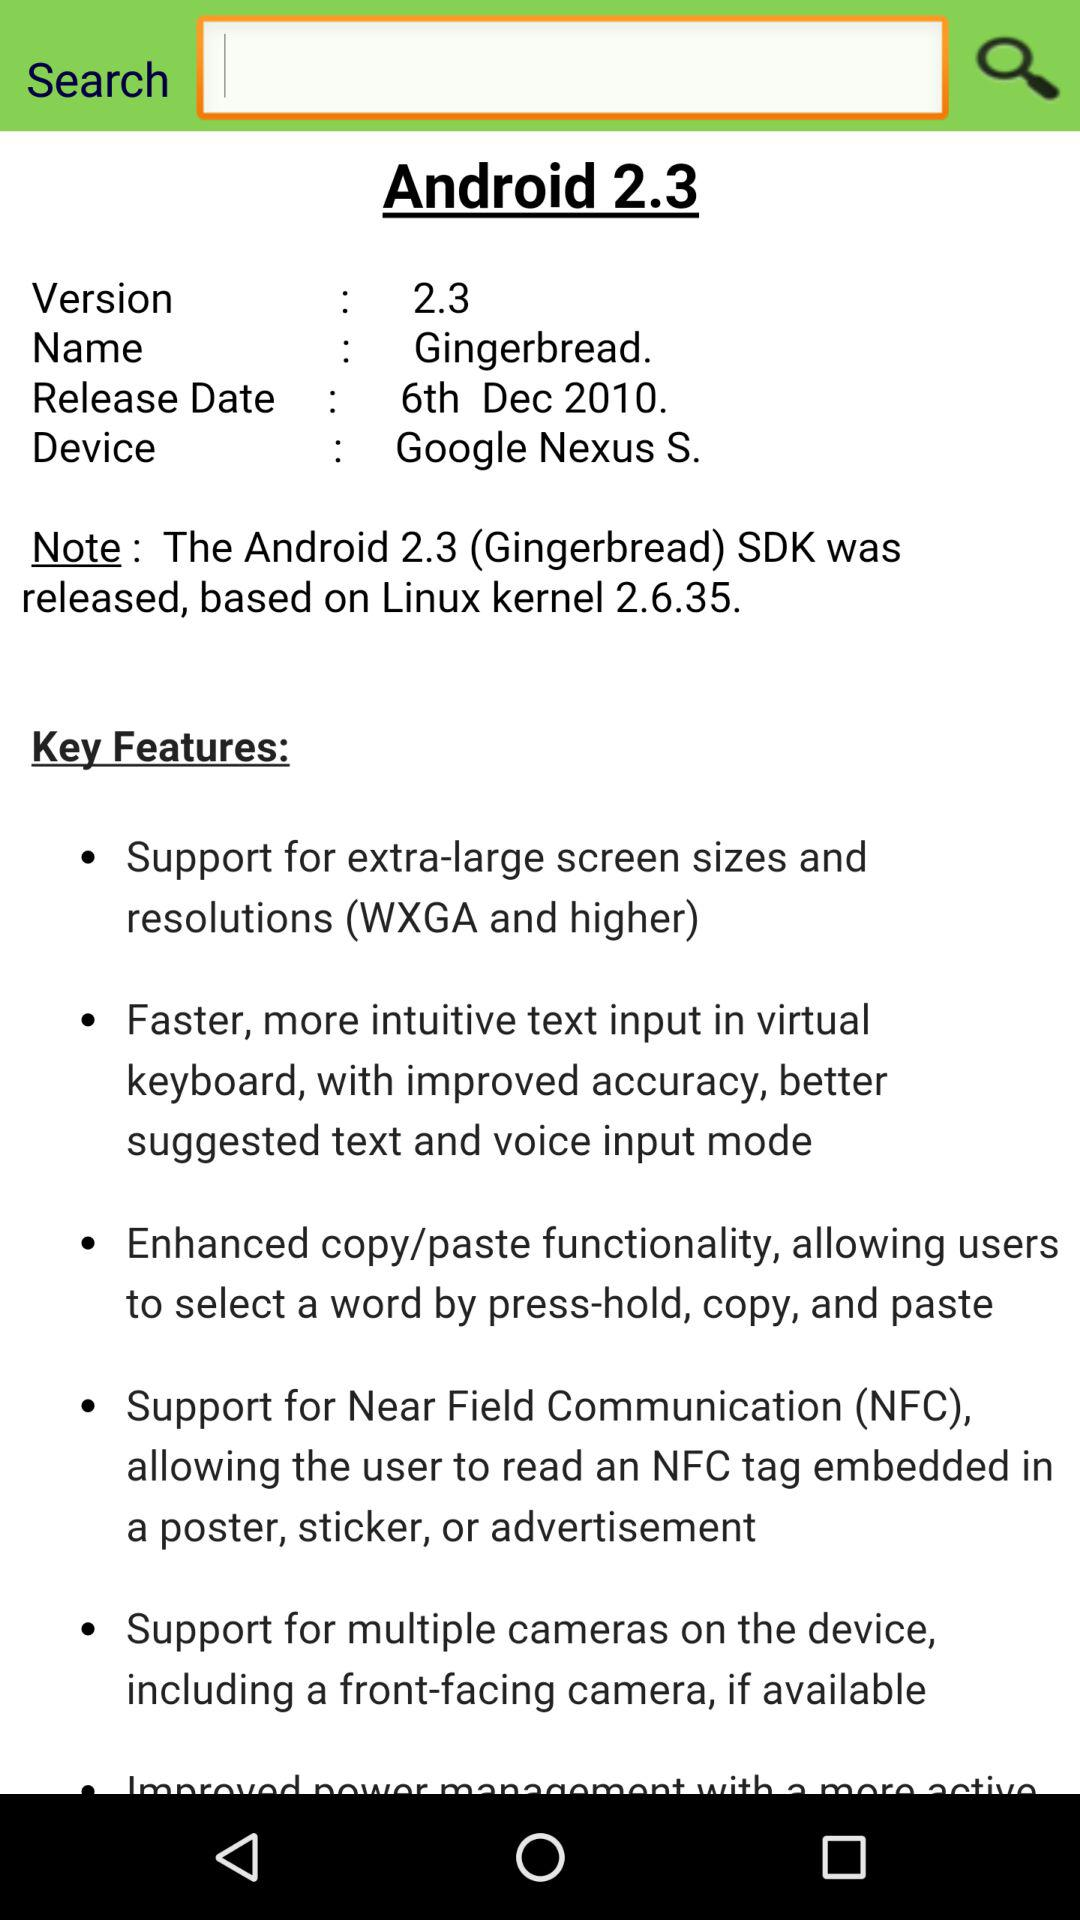What is the device name? The device name is "Google Nexus S.". 